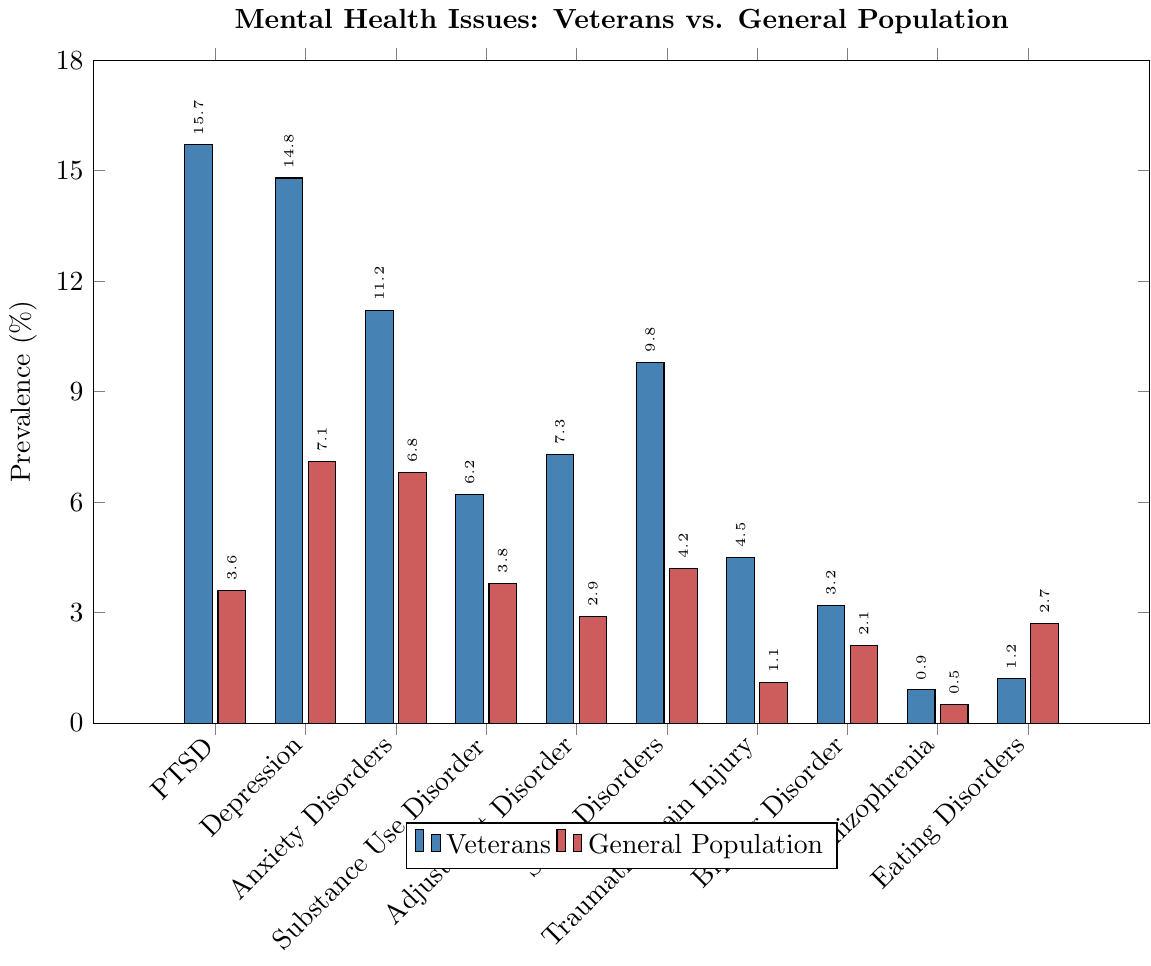Which condition shows the largest disparity in prevalence between veterans and the general population? To find the largest disparity, we need to compute the differences in prevalence for each condition between veterans and the general population. For PTSD, it's 15.7 - 3.6 = 12.1%; for Depression, it's 14.8 - 7.1 = 7.7%; for Anxiety Disorders, it's 11.2 - 6.8 = 4.4%; and so on. Comparing all these values, the largest disparity is for PTSD.
Answer: PTSD Which mental health condition has a higher prevalence in the general population compared to veterans? We need to compare the values for each condition between veterans and the general population. Most conditions have a higher prevalence in veterans except for Eating Disorders, where the general population has 2.7% compared to 1.2% in veterans.
Answer: Eating Disorders What's the sum of the prevalence rates of PTSD and Depression among veterans? We add the prevalence rates of PTSD (15.7%) and Depression (14.8%) among veterans. So, 15.7 + 14.8 = 30.5%.
Answer: 30.5% Are Sleep Disorders more prevalent among veterans than the general population? We compare the prevalence of Sleep Disorders among veterans (9.8%) with the general population (4.2%). Since 9.8% is greater than 4.2%, Sleep Disorders are more prevalent among veterans.
Answer: Yes Which mental health issue has the lowest prevalence among veterans? Comparing the prevalence rates among veterans, Schizophrenia has the lowest rate at 0.9%.
Answer: Schizophrenia What is the average prevalence rate of Anxiety Disorders and Substance Use Disorder in the general population? We calculate the average by adding the prevalence rates of Anxiety Disorders (6.8%) and Substance Use Disorder (3.8%) and dividing by 2. So, (6.8 + 3.8) / 2 = 5.3%.
Answer: 5.3% How much higher is the prevalence of Bipolar Disorder among veterans than the general population? We calculate the difference in prevalence of Bipolar Disorder between veterans (3.2%) and the general population (2.1%). So, 3.2 - 2.1 = 1.1%.
Answer: 1.1% 